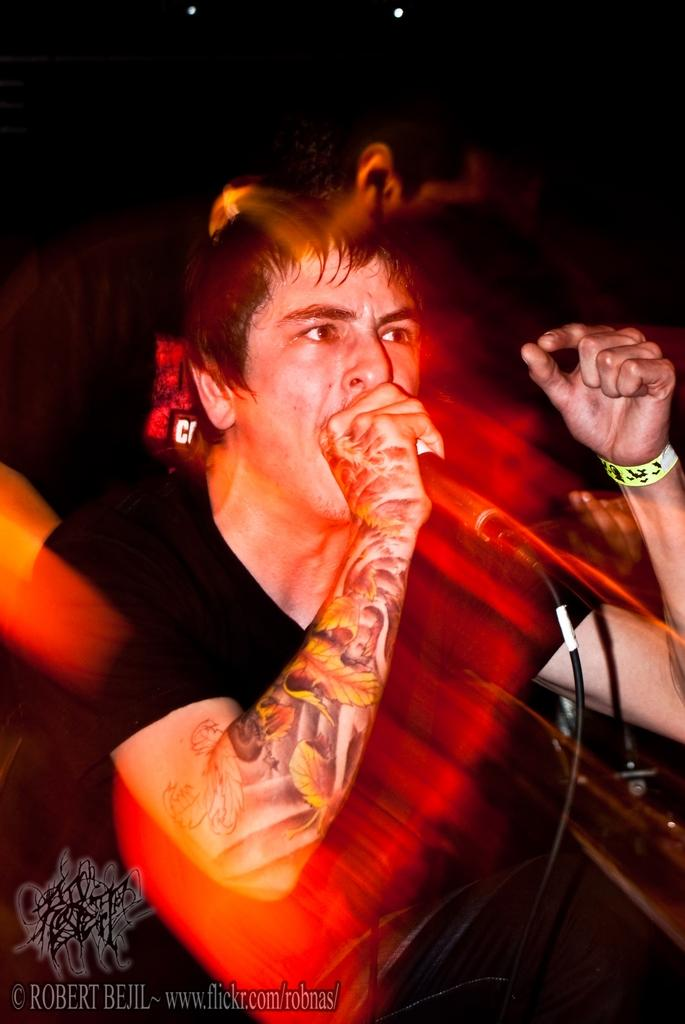What is the man in the image doing? The man is singing on a mic in the image. What is the man wearing on his upper body? The man is wearing a t-shirt in the image. What is the man wearing on his wrist? The man is wearing a band in the image. Can you describe any visual elements at the bottom of the image? There is a watermark at the bottom of the image. What type of lighting is visible in the image? There are lights visible at the top of the image. What is the overall lighting condition in the image? There is darkness visible at the top of the image. What grade does the man receive for his performance in the image? There is no indication of a grade or performance evaluation in the image. How does the man sort the items on the table in the image? There is no table or items to sort visible in the image. 